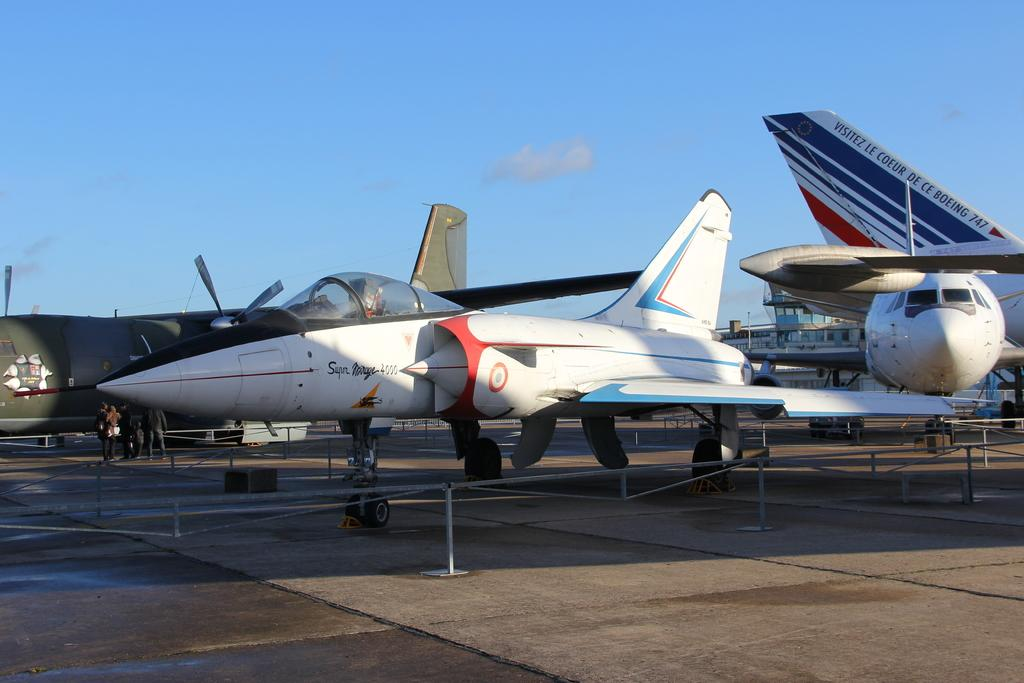<image>
Present a compact description of the photo's key features. a Beoing 747 is sitting beside some other planes 